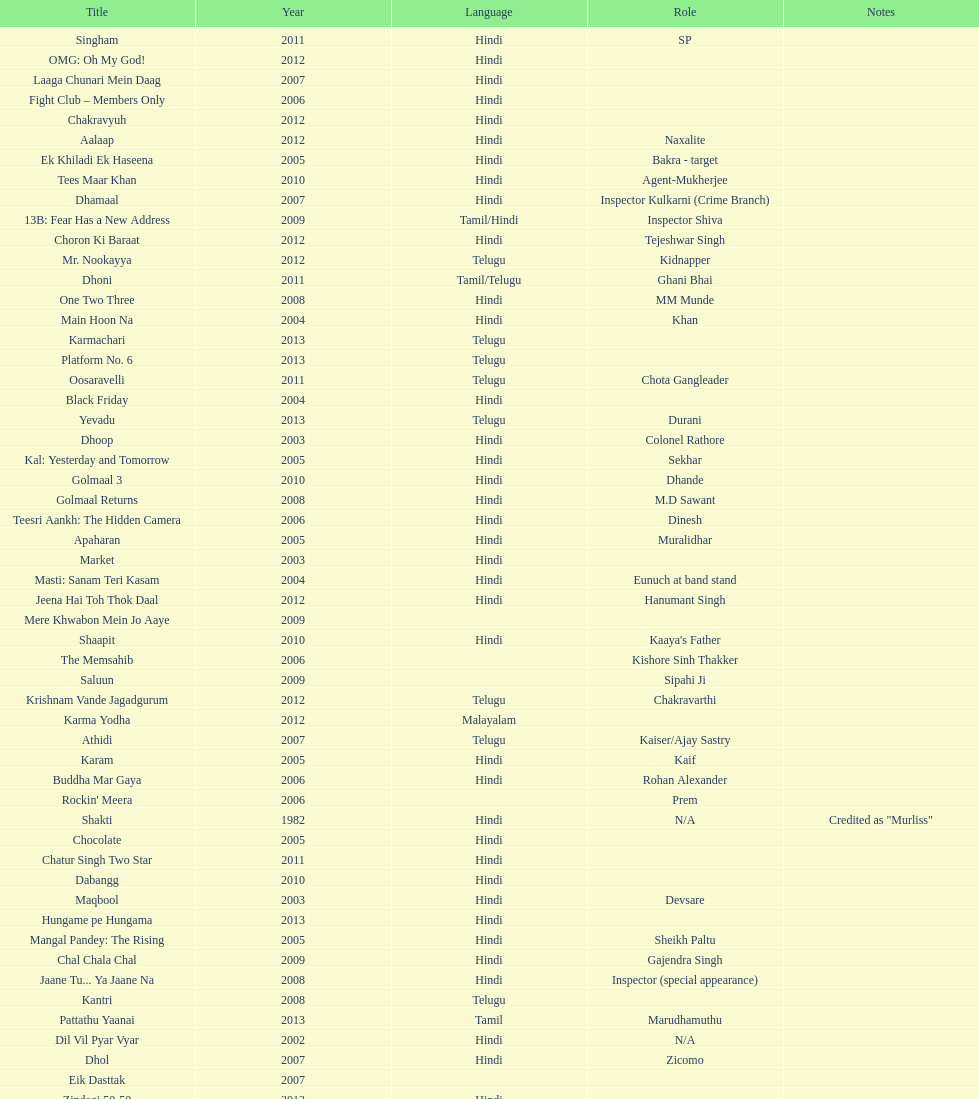Does maqbool have longer notes than shakti? No. 